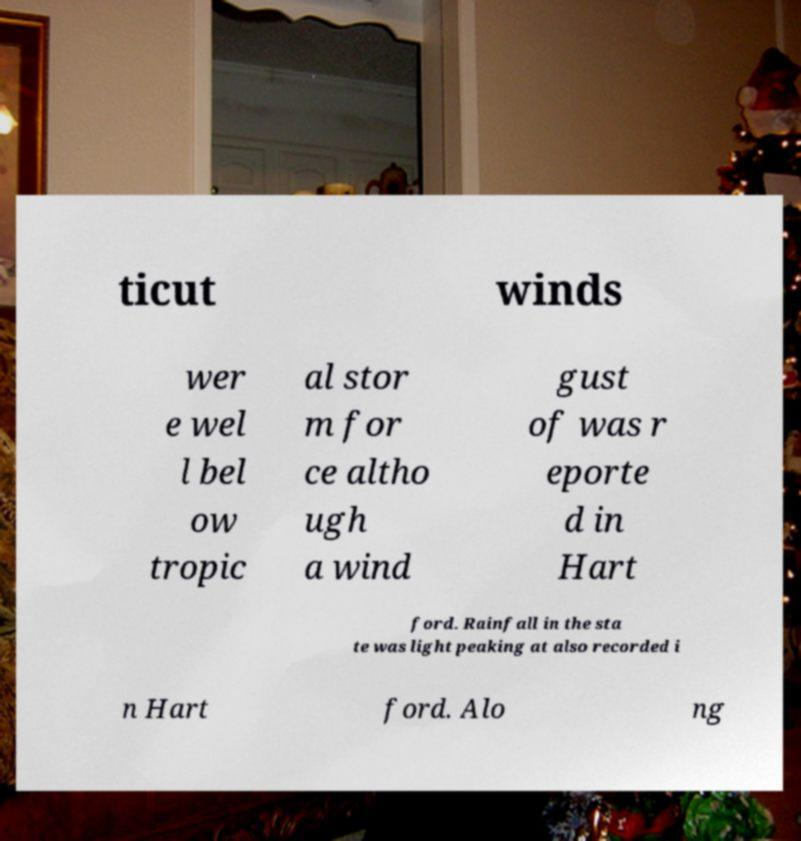For documentation purposes, I need the text within this image transcribed. Could you provide that? ticut winds wer e wel l bel ow tropic al stor m for ce altho ugh a wind gust of was r eporte d in Hart ford. Rainfall in the sta te was light peaking at also recorded i n Hart ford. Alo ng 